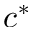<formula> <loc_0><loc_0><loc_500><loc_500>c ^ { * }</formula> 